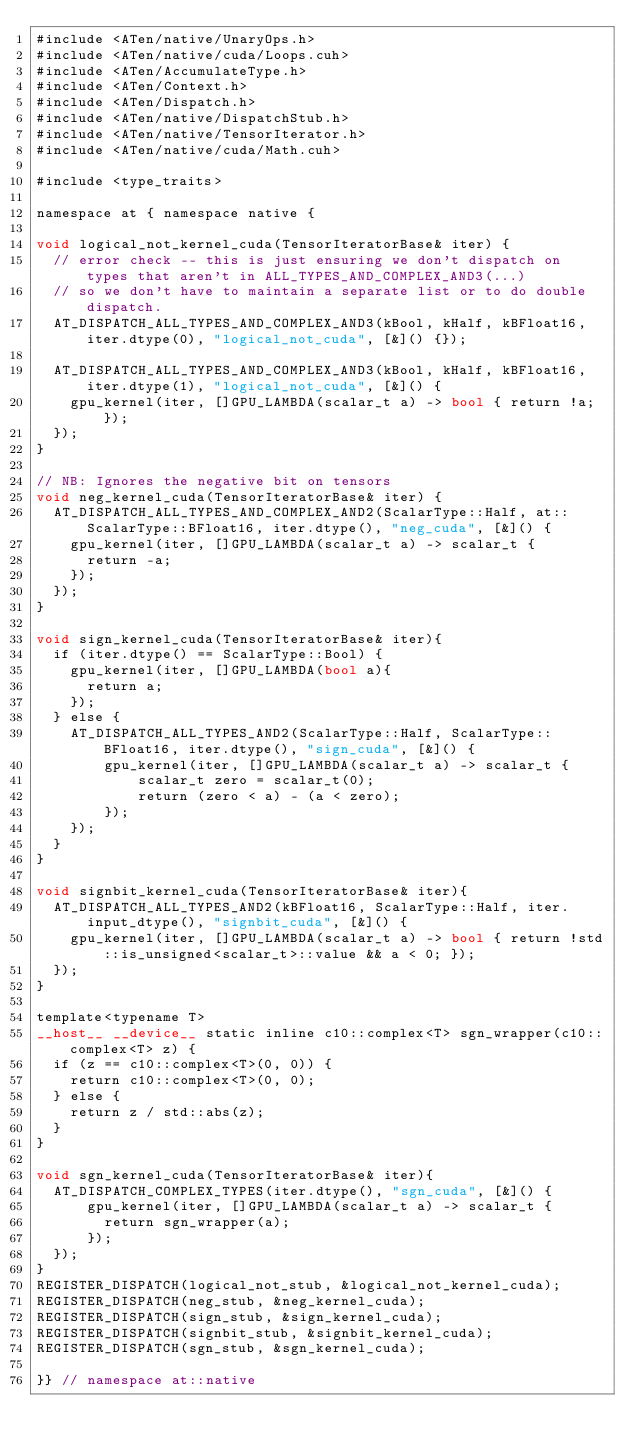Convert code to text. <code><loc_0><loc_0><loc_500><loc_500><_Cuda_>#include <ATen/native/UnaryOps.h>
#include <ATen/native/cuda/Loops.cuh>
#include <ATen/AccumulateType.h>
#include <ATen/Context.h>
#include <ATen/Dispatch.h>
#include <ATen/native/DispatchStub.h>
#include <ATen/native/TensorIterator.h>
#include <ATen/native/cuda/Math.cuh>

#include <type_traits>

namespace at { namespace native {

void logical_not_kernel_cuda(TensorIteratorBase& iter) {
  // error check -- this is just ensuring we don't dispatch on types that aren't in ALL_TYPES_AND_COMPLEX_AND3(...)
  // so we don't have to maintain a separate list or to do double dispatch.
  AT_DISPATCH_ALL_TYPES_AND_COMPLEX_AND3(kBool, kHalf, kBFloat16, iter.dtype(0), "logical_not_cuda", [&]() {});

  AT_DISPATCH_ALL_TYPES_AND_COMPLEX_AND3(kBool, kHalf, kBFloat16, iter.dtype(1), "logical_not_cuda", [&]() {
    gpu_kernel(iter, []GPU_LAMBDA(scalar_t a) -> bool { return !a; });
  });
}

// NB: Ignores the negative bit on tensors
void neg_kernel_cuda(TensorIteratorBase& iter) {
  AT_DISPATCH_ALL_TYPES_AND_COMPLEX_AND2(ScalarType::Half, at::ScalarType::BFloat16, iter.dtype(), "neg_cuda", [&]() {
    gpu_kernel(iter, []GPU_LAMBDA(scalar_t a) -> scalar_t {
      return -a;
    });
  });
}

void sign_kernel_cuda(TensorIteratorBase& iter){
  if (iter.dtype() == ScalarType::Bool) {
    gpu_kernel(iter, []GPU_LAMBDA(bool a){
      return a;
    });
  } else {
    AT_DISPATCH_ALL_TYPES_AND2(ScalarType::Half, ScalarType::BFloat16, iter.dtype(), "sign_cuda", [&]() {
        gpu_kernel(iter, []GPU_LAMBDA(scalar_t a) -> scalar_t {
            scalar_t zero = scalar_t(0);
            return (zero < a) - (a < zero);
        });
    });
  }
}

void signbit_kernel_cuda(TensorIteratorBase& iter){
  AT_DISPATCH_ALL_TYPES_AND2(kBFloat16, ScalarType::Half, iter.input_dtype(), "signbit_cuda", [&]() {
    gpu_kernel(iter, []GPU_LAMBDA(scalar_t a) -> bool { return !std::is_unsigned<scalar_t>::value && a < 0; });
  });
}

template<typename T>
__host__ __device__ static inline c10::complex<T> sgn_wrapper(c10::complex<T> z) {
  if (z == c10::complex<T>(0, 0)) {
    return c10::complex<T>(0, 0);
  } else {
    return z / std::abs(z);
  }
}

void sgn_kernel_cuda(TensorIteratorBase& iter){
  AT_DISPATCH_COMPLEX_TYPES(iter.dtype(), "sgn_cuda", [&]() {
      gpu_kernel(iter, []GPU_LAMBDA(scalar_t a) -> scalar_t {
        return sgn_wrapper(a);
      });
  });
}
REGISTER_DISPATCH(logical_not_stub, &logical_not_kernel_cuda);
REGISTER_DISPATCH(neg_stub, &neg_kernel_cuda);
REGISTER_DISPATCH(sign_stub, &sign_kernel_cuda);
REGISTER_DISPATCH(signbit_stub, &signbit_kernel_cuda);
REGISTER_DISPATCH(sgn_stub, &sgn_kernel_cuda);

}} // namespace at::native
</code> 